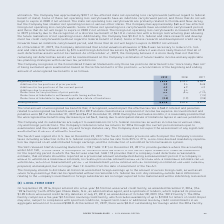From Roper Technologies's financial document, What were the accrued interest and penalties on December 31, 2018, and 2019, respectively? The document shows two values: $6.9 and $8.7. From the document: "t and penalties were $8.7 at December 31, 2019 and $6.9 at December 31, 2018. During the next twelve months, it is reasonably possible that the unreco..." Also, What were the ending balances of unrecognized tax benefits in fiscal 2017 and 2018, respectively? The document shows two values: $ 52.2 and $ 63.6. From the document: "Beginning balance $ 63.6 $ 52.2 $ 38.7 Beginning balance $ 63.6 $ 52.2 $ 38.7..." Also, What was the addition for tax positions of prior periods in 2019? According to the financial document, 2.9. The relevant text states: "Additions for tax positions of prior periods 2.9 2.4 24.8..." Also, can you calculate: What is the percentage change in the beginning and ending balance of unrecognized tax benefits in 2019? To answer this question, I need to perform calculations using the financial data. The calculation is: (69.8-63.6)/63.6 , which equals 9.75 (percentage). This is based on the information: "Ending balance $ 69.8 $ 63.6 $ 52.2 Ending balance $ 69.8 $ 63.6 $ 52.2..." The key data points involved are: 63.6, 69.8. Also, can you calculate: What is the ratio of total additions to total reductions of unrecognized tax benefits during the fiscal year 2017? To answer this question, I need to perform calculations using the financial data. The calculation is: (24.8+4.2)/(11.2+1.5+2.8) , which equals 1.87. This is based on the information: "of applicable statute of limitations (2.5) (1.9) (2.8) table to settlements with taxing authorities — — (1.5) Additions for tax positions of the current period 4.2 6.9 4.2 s for tax positions of prior..." The key data points involved are: 1.5, 11.2, 2.8. Also, can you calculate: What is the average ending balance of unrecognized tax benefits from 2017 to 2019? To answer this question, I need to perform calculations using the financial data. The calculation is: (69.8+63.6+52.2)/3 , which equals 61.87. This is based on the information: "Beginning balance $ 63.6 $ 52.2 $ 38.7 Beginning balance $ 63.6 $ 52.2 $ 38.7 Ending balance $ 69.8 $ 63.6 $ 52.2..." The key data points involved are: 52.2, 63.6, 69.8. 